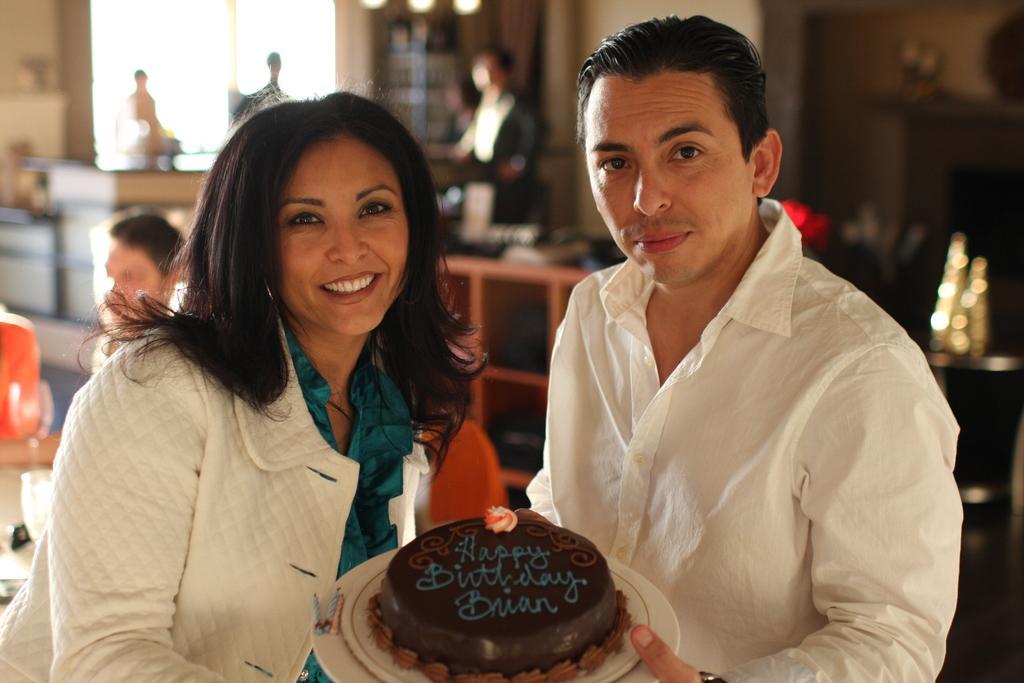In one or two sentences, can you explain what this image depicts? In this image I see a man who is wearing white shirt and I see a woman who is wearing white and blue top and I see that both of them are holding a plate on which there is a cake which is of dark brown in color and I see 3 words written on it and I see that this woman is smiling. In the background I see few people and I see that it is blurred in the background. 